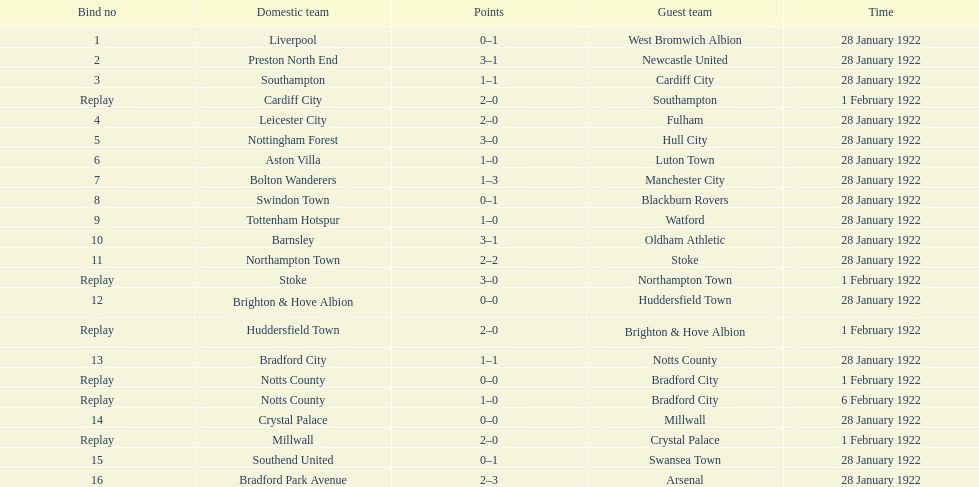How many games had four total points scored or more? 5. 